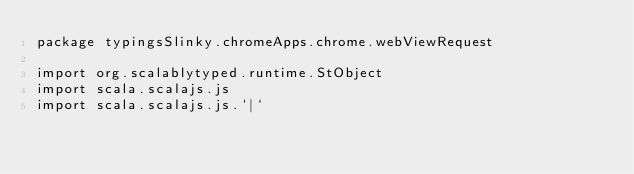Convert code to text. <code><loc_0><loc_0><loc_500><loc_500><_Scala_>package typingsSlinky.chromeApps.chrome.webViewRequest

import org.scalablytyped.runtime.StObject
import scala.scalajs.js
import scala.scalajs.js.`|`</code> 